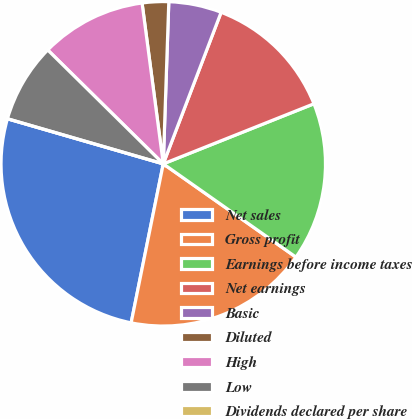Convert chart. <chart><loc_0><loc_0><loc_500><loc_500><pie_chart><fcel>Net sales<fcel>Gross profit<fcel>Earnings before income taxes<fcel>Net earnings<fcel>Basic<fcel>Diluted<fcel>High<fcel>Low<fcel>Dividends declared per share<nl><fcel>26.31%<fcel>18.42%<fcel>15.79%<fcel>13.16%<fcel>5.26%<fcel>2.63%<fcel>10.53%<fcel>7.9%<fcel>0.0%<nl></chart> 